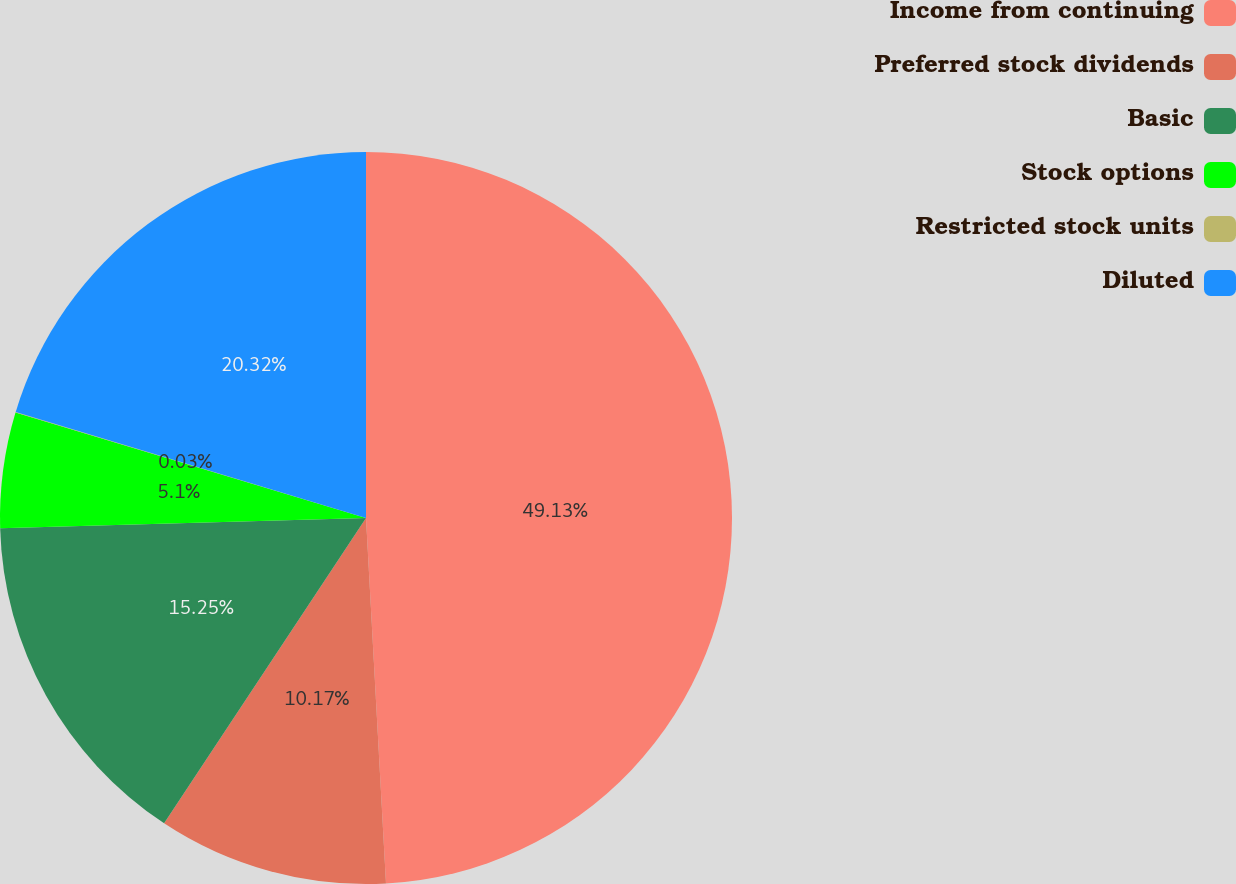<chart> <loc_0><loc_0><loc_500><loc_500><pie_chart><fcel>Income from continuing<fcel>Preferred stock dividends<fcel>Basic<fcel>Stock options<fcel>Restricted stock units<fcel>Diluted<nl><fcel>49.13%<fcel>10.17%<fcel>15.25%<fcel>5.1%<fcel>0.03%<fcel>20.32%<nl></chart> 